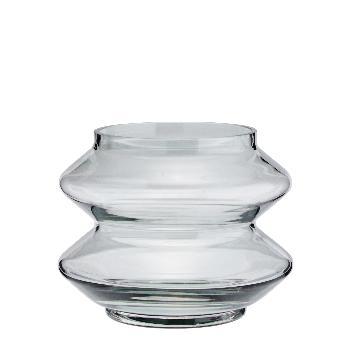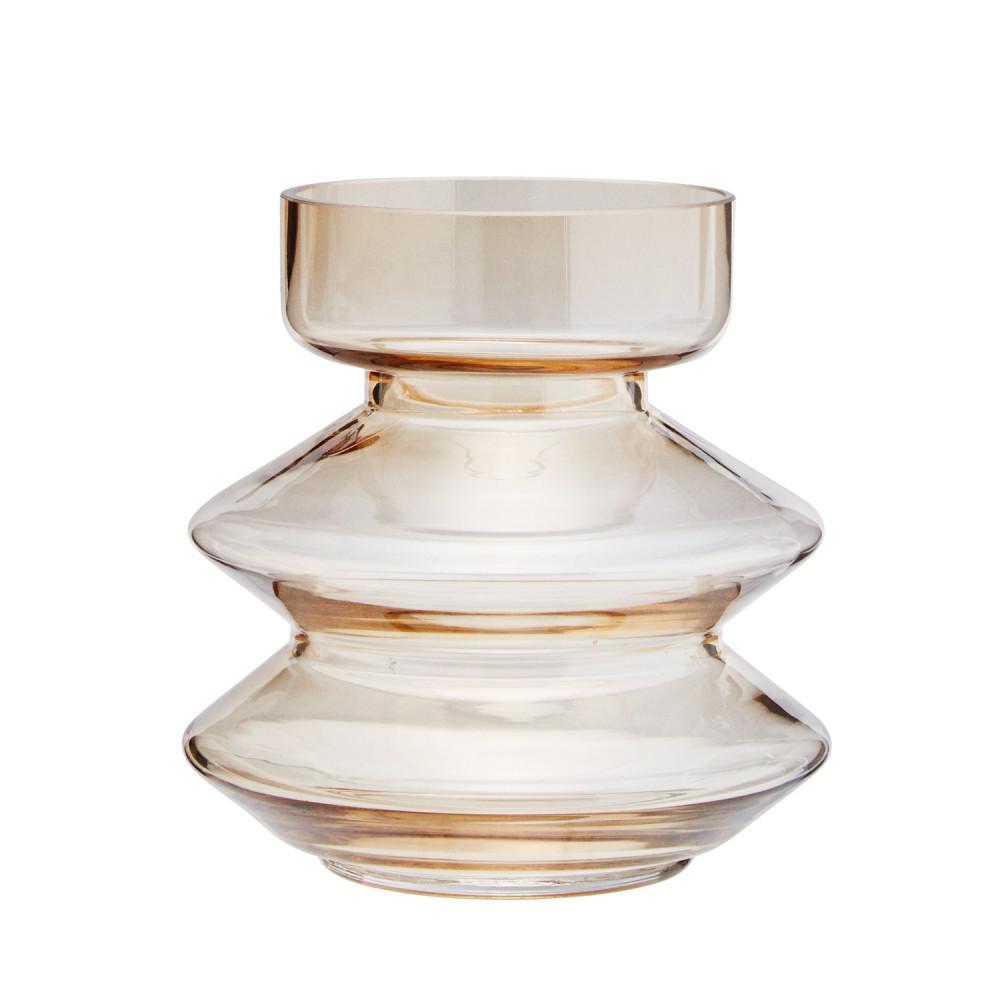The first image is the image on the left, the second image is the image on the right. Considering the images on both sides, is "An image shows a jar with a flower in it." valid? Answer yes or no. No. The first image is the image on the left, the second image is the image on the right. Considering the images on both sides, is "The number of jars in one image without lids is the same number in the other image with lids." valid? Answer yes or no. Yes. 